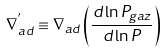<formula> <loc_0><loc_0><loc_500><loc_500>\nabla ^ { ^ { \prime } } _ { a d } \equiv \nabla _ { a d } \left ( \frac { d \ln P _ { g a z } } { d \ln P } \right )</formula> 